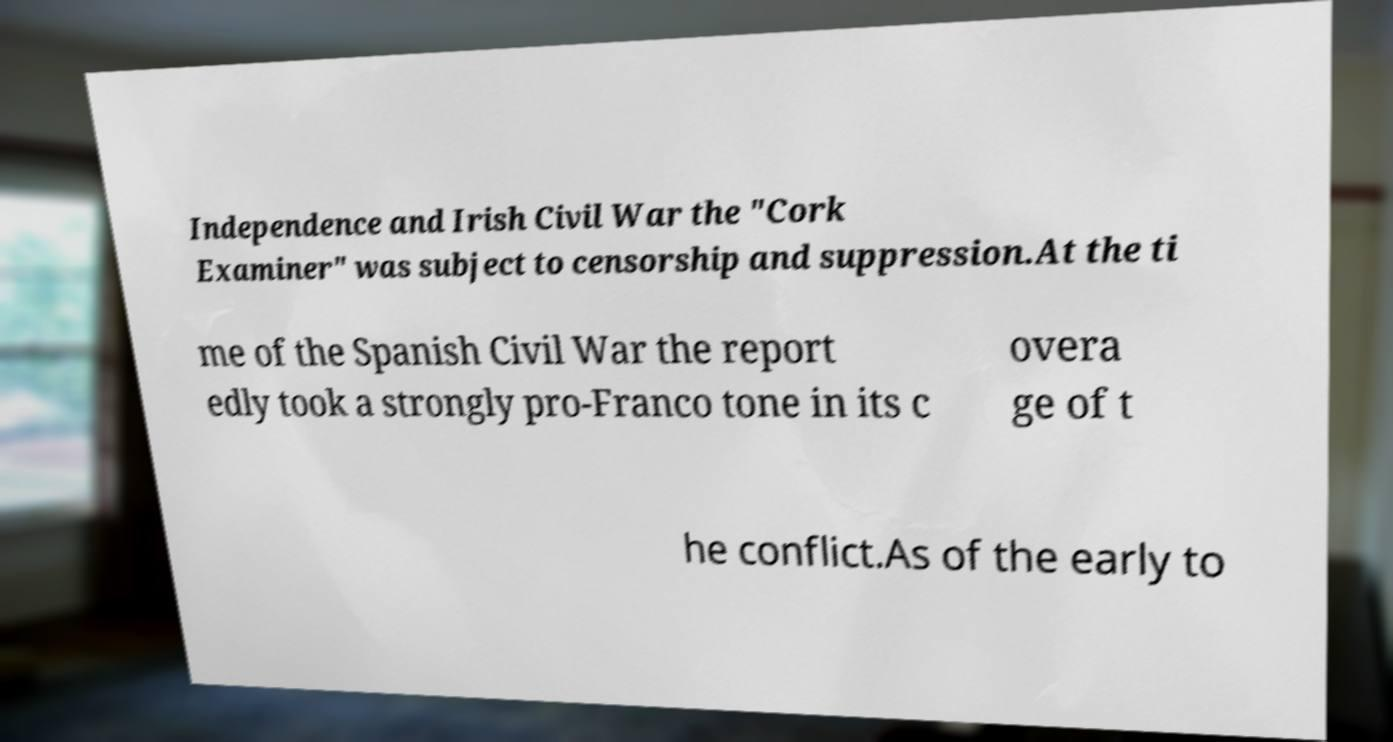I need the written content from this picture converted into text. Can you do that? Independence and Irish Civil War the "Cork Examiner" was subject to censorship and suppression.At the ti me of the Spanish Civil War the report edly took a strongly pro-Franco tone in its c overa ge of t he conflict.As of the early to 